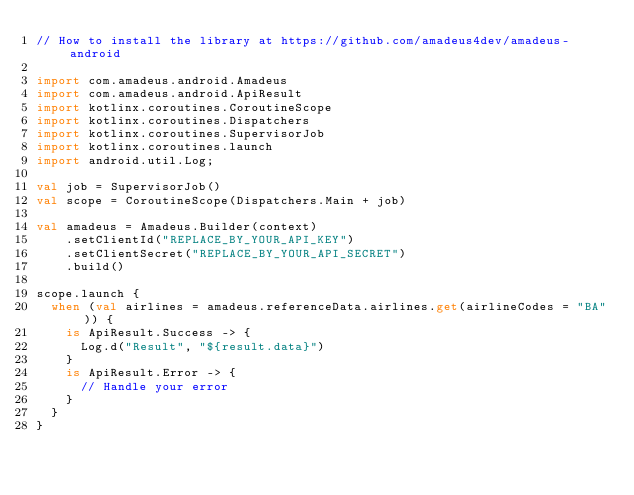<code> <loc_0><loc_0><loc_500><loc_500><_Kotlin_>// How to install the library at https://github.com/amadeus4dev/amadeus-android

import com.amadeus.android.Amadeus
import com.amadeus.android.ApiResult
import kotlinx.coroutines.CoroutineScope
import kotlinx.coroutines.Dispatchers
import kotlinx.coroutines.SupervisorJob
import kotlinx.coroutines.launch
import android.util.Log;

val job = SupervisorJob()
val scope = CoroutineScope(Dispatchers.Main + job)

val amadeus = Amadeus.Builder(context)
    .setClientId("REPLACE_BY_YOUR_API_KEY")
    .setClientSecret("REPLACE_BY_YOUR_API_SECRET")
    .build()

scope.launch {
  when (val airlines = amadeus.referenceData.airlines.get(airlineCodes = "BA")) {
    is ApiResult.Success -> {
      Log.d("Result", "${result.data}")
    }
    is ApiResult.Error -> {
      // Handle your error
    }
  }
}
</code> 